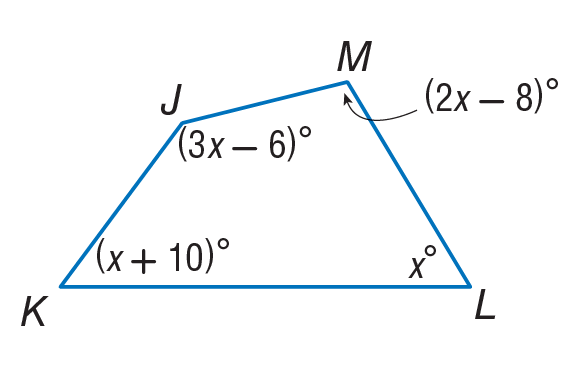Answer the mathemtical geometry problem and directly provide the correct option letter.
Question: Find m \angle J.
Choices: A: 52 B: 62 C: 72 D: 150 D 